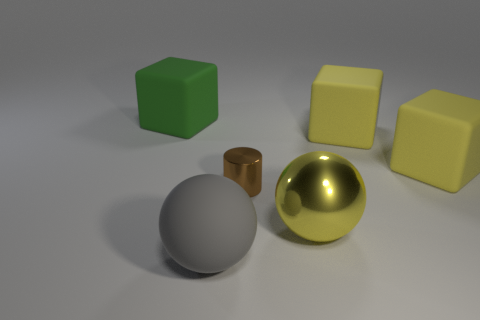Subtract all large green blocks. How many blocks are left? 2 Subtract all blue cylinders. How many yellow cubes are left? 2 Add 1 tiny blue metal balls. How many objects exist? 7 Subtract all spheres. How many objects are left? 4 Subtract 0 red balls. How many objects are left? 6 Subtract all green rubber cylinders. Subtract all tiny cylinders. How many objects are left? 5 Add 6 large yellow balls. How many large yellow balls are left? 7 Add 2 shiny objects. How many shiny objects exist? 4 